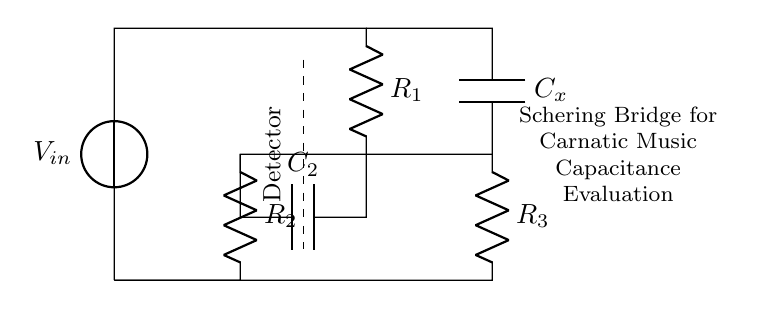What is the type of this circuit? This circuit is a Schering bridge, which is specifically designed to measure capacitance. This can be inferred because it features capacitors prominently and is structured to balance impedance, a common principle in Schering bridge configurations.
Answer: Schering bridge What is the function of the voltage source? The voltage source provides the input voltage necessary to energize the circuit. In a bridge configuration, it allows for the detection of differences in impedance between branches, which is critical for evaluating capacitance.
Answer: Voltage source How many resistors are in this circuit? There are three resistors visible in the circuit diagram, labeled R1, R2, and R3. They are arranged strategically to balance the bridge and facilitate the measurement.
Answer: Three What component is represented by C2? C2 is a capacitor in the Schering bridge, and it functions to create an impedance that allows the bridge to measure the unknown capacitance of Cx accurately. This component is essential for determining capacitance by comparing it to the known reference capacitor C2.
Answer: Capacitor What does the dashed line indicate in the diagram? The dashed line represents a reference to the detection point within the circuit, where measurements are typically taken to determine if the bridge is balanced. It is important for indicating where to connect a measuring instrument or detector.
Answer: Detector What is the relationship between Cx and C2 for balance? For the Schering bridge to be balanced, the relationship can be expressed as the ratio of the known capacitor C2 to the unknown capacitor Cx being equal to the ratio of the resistances R1 and R2. This balance condition allows for accurate capacitance measurement.
Answer: R1/R2 = C2/Cx What is the purpose of the circuit labeled as "Schering Bridge for Carnatic Music Capacitance Evaluation"? This labeling indicates that the specific application of this Schering bridge is to evaluate capacitance related to digital audio interfaces in Carnatic music performances, suggesting significance in audio quality and signal integrity during recordings.
Answer: Capacitance evaluation 